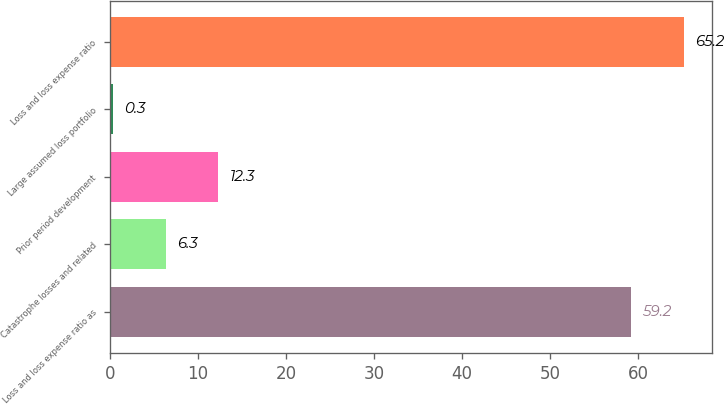<chart> <loc_0><loc_0><loc_500><loc_500><bar_chart><fcel>Loss and loss expense ratio as<fcel>Catastrophe losses and related<fcel>Prior period development<fcel>Large assumed loss portfolio<fcel>Loss and loss expense ratio<nl><fcel>59.2<fcel>6.3<fcel>12.3<fcel>0.3<fcel>65.2<nl></chart> 